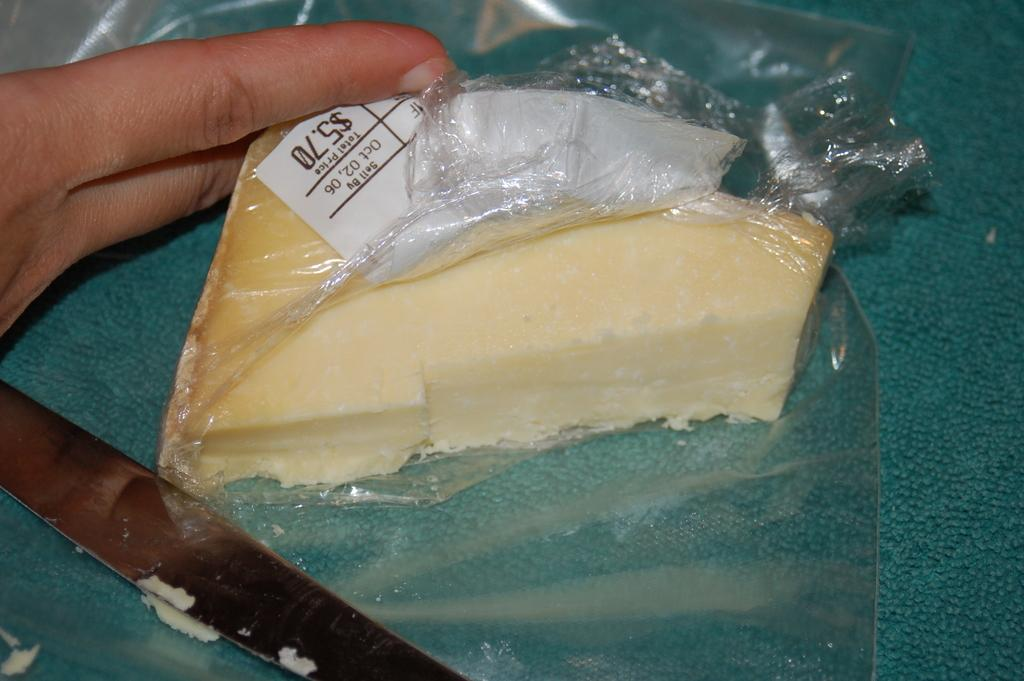What is inside the cover that is visible in the image? There is a cheese in the cover in the image. What object is on the carpet in the image? There is a knife on the carpet in the image. Whose fingers are holding the cover in the image? A person's fingers are holding the cover in the image. What country is the person in the image from? There is no information about the person's country of origin in the image. How does the cheese feel about being held in the cover? The cheese is an inanimate object and does not have feelings or emotions. 